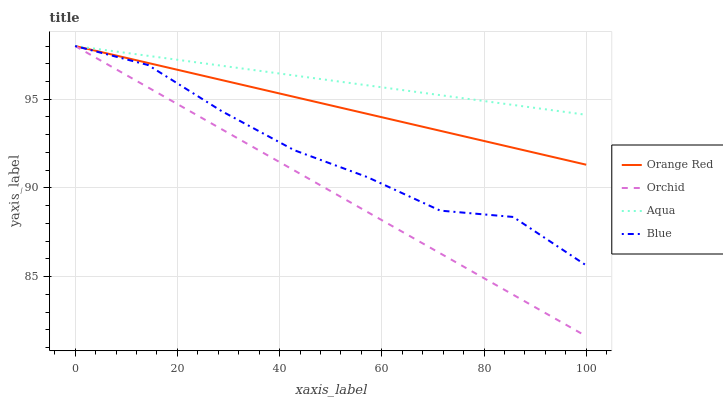Does Orchid have the minimum area under the curve?
Answer yes or no. Yes. Does Aqua have the maximum area under the curve?
Answer yes or no. Yes. Does Orange Red have the minimum area under the curve?
Answer yes or no. No. Does Orange Red have the maximum area under the curve?
Answer yes or no. No. Is Orchid the smoothest?
Answer yes or no. Yes. Is Blue the roughest?
Answer yes or no. Yes. Is Aqua the smoothest?
Answer yes or no. No. Is Aqua the roughest?
Answer yes or no. No. Does Orchid have the lowest value?
Answer yes or no. Yes. Does Orange Red have the lowest value?
Answer yes or no. No. Does Orchid have the highest value?
Answer yes or no. Yes. Does Orchid intersect Blue?
Answer yes or no. Yes. Is Orchid less than Blue?
Answer yes or no. No. Is Orchid greater than Blue?
Answer yes or no. No. 